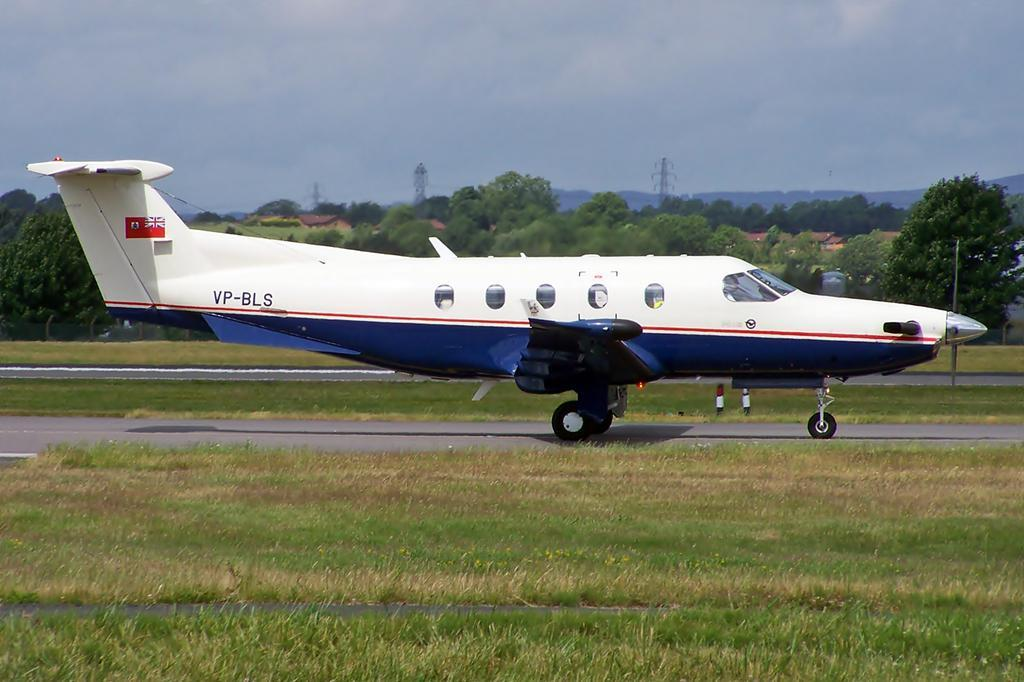What is the main subject of the image? The main subject of the image is a plane on the runway. What can be seen on the ground on either side of the plane? There is greenery on the ground on either side of the plane. What is visible in the background of the image? There are trees, buildings, and towers in the background of the image. How many quarters can be seen on the plane in the image? There are no quarters visible on the plane in the image. Are there any worms crawling on the plane in the image? There are no worms visible on the plane in the image. 